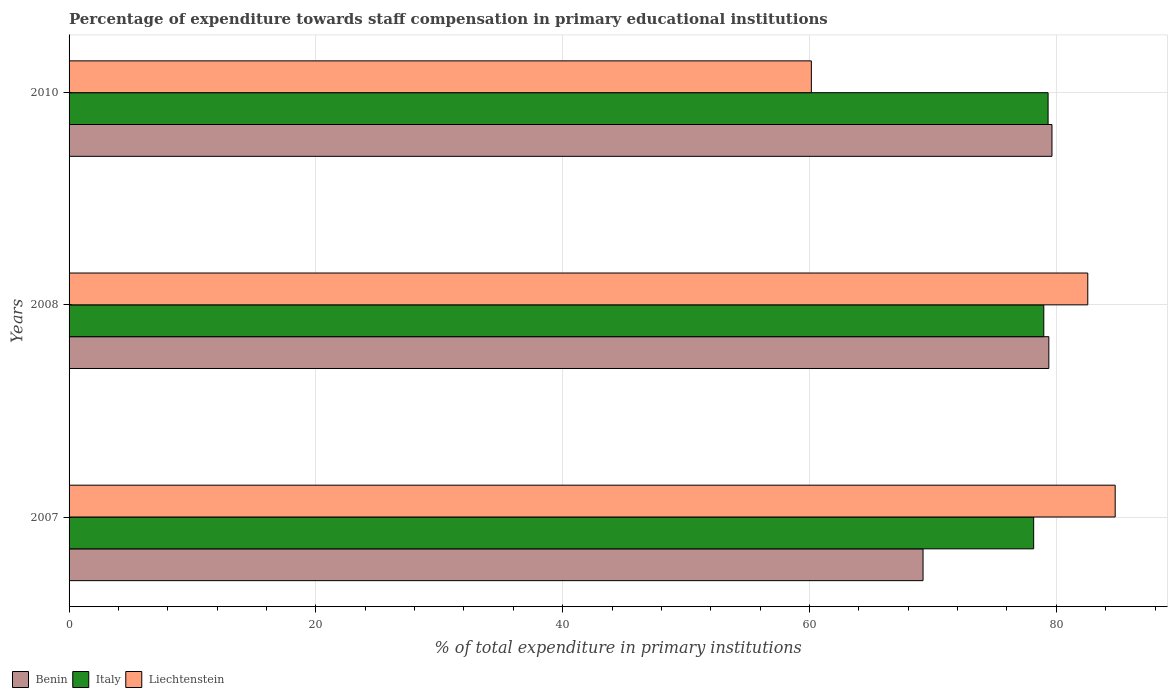Are the number of bars per tick equal to the number of legend labels?
Your answer should be very brief. Yes. Are the number of bars on each tick of the Y-axis equal?
Your answer should be compact. Yes. How many bars are there on the 2nd tick from the top?
Give a very brief answer. 3. What is the label of the 2nd group of bars from the top?
Offer a very short reply. 2008. In how many cases, is the number of bars for a given year not equal to the number of legend labels?
Offer a terse response. 0. What is the percentage of expenditure towards staff compensation in Liechtenstein in 2008?
Offer a very short reply. 82.55. Across all years, what is the maximum percentage of expenditure towards staff compensation in Italy?
Keep it short and to the point. 79.33. Across all years, what is the minimum percentage of expenditure towards staff compensation in Italy?
Your response must be concise. 78.17. In which year was the percentage of expenditure towards staff compensation in Liechtenstein minimum?
Ensure brevity in your answer.  2010. What is the total percentage of expenditure towards staff compensation in Italy in the graph?
Your answer should be compact. 236.49. What is the difference between the percentage of expenditure towards staff compensation in Benin in 2007 and that in 2010?
Provide a short and direct response. -10.45. What is the difference between the percentage of expenditure towards staff compensation in Italy in 2008 and the percentage of expenditure towards staff compensation in Benin in 2007?
Offer a terse response. 9.78. What is the average percentage of expenditure towards staff compensation in Benin per year?
Give a very brief answer. 76.08. In the year 2010, what is the difference between the percentage of expenditure towards staff compensation in Liechtenstein and percentage of expenditure towards staff compensation in Italy?
Give a very brief answer. -19.18. In how many years, is the percentage of expenditure towards staff compensation in Benin greater than 56 %?
Provide a succinct answer. 3. What is the ratio of the percentage of expenditure towards staff compensation in Liechtenstein in 2007 to that in 2008?
Offer a terse response. 1.03. Is the percentage of expenditure towards staff compensation in Benin in 2007 less than that in 2008?
Offer a very short reply. Yes. What is the difference between the highest and the second highest percentage of expenditure towards staff compensation in Liechtenstein?
Offer a very short reply. 2.22. What is the difference between the highest and the lowest percentage of expenditure towards staff compensation in Italy?
Provide a short and direct response. 1.17. In how many years, is the percentage of expenditure towards staff compensation in Italy greater than the average percentage of expenditure towards staff compensation in Italy taken over all years?
Offer a terse response. 2. What does the 2nd bar from the top in 2008 represents?
Provide a short and direct response. Italy. How many bars are there?
Offer a very short reply. 9. How many years are there in the graph?
Provide a short and direct response. 3. What is the difference between two consecutive major ticks on the X-axis?
Your answer should be very brief. 20. How are the legend labels stacked?
Provide a short and direct response. Horizontal. What is the title of the graph?
Keep it short and to the point. Percentage of expenditure towards staff compensation in primary educational institutions. What is the label or title of the X-axis?
Offer a very short reply. % of total expenditure in primary institutions. What is the % of total expenditure in primary institutions in Benin in 2007?
Provide a succinct answer. 69.2. What is the % of total expenditure in primary institutions in Italy in 2007?
Offer a very short reply. 78.17. What is the % of total expenditure in primary institutions of Liechtenstein in 2007?
Keep it short and to the point. 84.77. What is the % of total expenditure in primary institutions in Benin in 2008?
Your response must be concise. 79.39. What is the % of total expenditure in primary institutions in Italy in 2008?
Provide a short and direct response. 78.99. What is the % of total expenditure in primary institutions of Liechtenstein in 2008?
Offer a terse response. 82.55. What is the % of total expenditure in primary institutions in Benin in 2010?
Your response must be concise. 79.65. What is the % of total expenditure in primary institutions in Italy in 2010?
Your response must be concise. 79.33. What is the % of total expenditure in primary institutions of Liechtenstein in 2010?
Your answer should be very brief. 60.15. Across all years, what is the maximum % of total expenditure in primary institutions in Benin?
Make the answer very short. 79.65. Across all years, what is the maximum % of total expenditure in primary institutions in Italy?
Your answer should be very brief. 79.33. Across all years, what is the maximum % of total expenditure in primary institutions in Liechtenstein?
Provide a short and direct response. 84.77. Across all years, what is the minimum % of total expenditure in primary institutions in Benin?
Give a very brief answer. 69.2. Across all years, what is the minimum % of total expenditure in primary institutions of Italy?
Keep it short and to the point. 78.17. Across all years, what is the minimum % of total expenditure in primary institutions of Liechtenstein?
Keep it short and to the point. 60.15. What is the total % of total expenditure in primary institutions in Benin in the graph?
Provide a short and direct response. 228.24. What is the total % of total expenditure in primary institutions in Italy in the graph?
Keep it short and to the point. 236.49. What is the total % of total expenditure in primary institutions of Liechtenstein in the graph?
Offer a very short reply. 227.47. What is the difference between the % of total expenditure in primary institutions in Benin in 2007 and that in 2008?
Make the answer very short. -10.19. What is the difference between the % of total expenditure in primary institutions in Italy in 2007 and that in 2008?
Provide a short and direct response. -0.82. What is the difference between the % of total expenditure in primary institutions of Liechtenstein in 2007 and that in 2008?
Your answer should be compact. 2.22. What is the difference between the % of total expenditure in primary institutions in Benin in 2007 and that in 2010?
Give a very brief answer. -10.45. What is the difference between the % of total expenditure in primary institutions in Italy in 2007 and that in 2010?
Provide a succinct answer. -1.17. What is the difference between the % of total expenditure in primary institutions in Liechtenstein in 2007 and that in 2010?
Your response must be concise. 24.62. What is the difference between the % of total expenditure in primary institutions in Benin in 2008 and that in 2010?
Provide a succinct answer. -0.25. What is the difference between the % of total expenditure in primary institutions of Italy in 2008 and that in 2010?
Give a very brief answer. -0.35. What is the difference between the % of total expenditure in primary institutions of Liechtenstein in 2008 and that in 2010?
Offer a terse response. 22.4. What is the difference between the % of total expenditure in primary institutions in Benin in 2007 and the % of total expenditure in primary institutions in Italy in 2008?
Your response must be concise. -9.78. What is the difference between the % of total expenditure in primary institutions in Benin in 2007 and the % of total expenditure in primary institutions in Liechtenstein in 2008?
Make the answer very short. -13.35. What is the difference between the % of total expenditure in primary institutions in Italy in 2007 and the % of total expenditure in primary institutions in Liechtenstein in 2008?
Keep it short and to the point. -4.38. What is the difference between the % of total expenditure in primary institutions of Benin in 2007 and the % of total expenditure in primary institutions of Italy in 2010?
Offer a terse response. -10.13. What is the difference between the % of total expenditure in primary institutions in Benin in 2007 and the % of total expenditure in primary institutions in Liechtenstein in 2010?
Give a very brief answer. 9.05. What is the difference between the % of total expenditure in primary institutions of Italy in 2007 and the % of total expenditure in primary institutions of Liechtenstein in 2010?
Offer a very short reply. 18.02. What is the difference between the % of total expenditure in primary institutions in Benin in 2008 and the % of total expenditure in primary institutions in Italy in 2010?
Provide a succinct answer. 0.06. What is the difference between the % of total expenditure in primary institutions in Benin in 2008 and the % of total expenditure in primary institutions in Liechtenstein in 2010?
Make the answer very short. 19.24. What is the difference between the % of total expenditure in primary institutions of Italy in 2008 and the % of total expenditure in primary institutions of Liechtenstein in 2010?
Provide a short and direct response. 18.84. What is the average % of total expenditure in primary institutions in Benin per year?
Your answer should be compact. 76.08. What is the average % of total expenditure in primary institutions of Italy per year?
Your answer should be compact. 78.83. What is the average % of total expenditure in primary institutions of Liechtenstein per year?
Keep it short and to the point. 75.82. In the year 2007, what is the difference between the % of total expenditure in primary institutions in Benin and % of total expenditure in primary institutions in Italy?
Keep it short and to the point. -8.96. In the year 2007, what is the difference between the % of total expenditure in primary institutions of Benin and % of total expenditure in primary institutions of Liechtenstein?
Make the answer very short. -15.57. In the year 2007, what is the difference between the % of total expenditure in primary institutions of Italy and % of total expenditure in primary institutions of Liechtenstein?
Offer a very short reply. -6.6. In the year 2008, what is the difference between the % of total expenditure in primary institutions of Benin and % of total expenditure in primary institutions of Italy?
Make the answer very short. 0.41. In the year 2008, what is the difference between the % of total expenditure in primary institutions in Benin and % of total expenditure in primary institutions in Liechtenstein?
Your answer should be very brief. -3.16. In the year 2008, what is the difference between the % of total expenditure in primary institutions of Italy and % of total expenditure in primary institutions of Liechtenstein?
Make the answer very short. -3.56. In the year 2010, what is the difference between the % of total expenditure in primary institutions in Benin and % of total expenditure in primary institutions in Italy?
Provide a succinct answer. 0.31. In the year 2010, what is the difference between the % of total expenditure in primary institutions in Benin and % of total expenditure in primary institutions in Liechtenstein?
Your response must be concise. 19.5. In the year 2010, what is the difference between the % of total expenditure in primary institutions of Italy and % of total expenditure in primary institutions of Liechtenstein?
Provide a short and direct response. 19.18. What is the ratio of the % of total expenditure in primary institutions of Benin in 2007 to that in 2008?
Ensure brevity in your answer.  0.87. What is the ratio of the % of total expenditure in primary institutions in Liechtenstein in 2007 to that in 2008?
Provide a short and direct response. 1.03. What is the ratio of the % of total expenditure in primary institutions in Benin in 2007 to that in 2010?
Ensure brevity in your answer.  0.87. What is the ratio of the % of total expenditure in primary institutions in Liechtenstein in 2007 to that in 2010?
Provide a succinct answer. 1.41. What is the ratio of the % of total expenditure in primary institutions of Liechtenstein in 2008 to that in 2010?
Your response must be concise. 1.37. What is the difference between the highest and the second highest % of total expenditure in primary institutions of Benin?
Your answer should be compact. 0.25. What is the difference between the highest and the second highest % of total expenditure in primary institutions in Italy?
Your response must be concise. 0.35. What is the difference between the highest and the second highest % of total expenditure in primary institutions in Liechtenstein?
Provide a short and direct response. 2.22. What is the difference between the highest and the lowest % of total expenditure in primary institutions of Benin?
Offer a very short reply. 10.45. What is the difference between the highest and the lowest % of total expenditure in primary institutions in Italy?
Offer a terse response. 1.17. What is the difference between the highest and the lowest % of total expenditure in primary institutions of Liechtenstein?
Give a very brief answer. 24.62. 